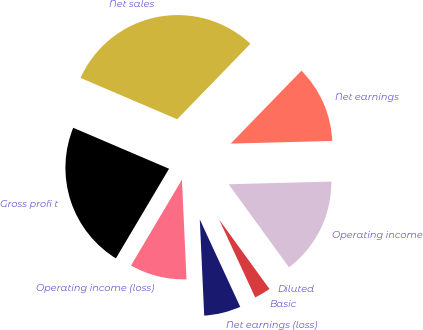Convert chart to OTSL. <chart><loc_0><loc_0><loc_500><loc_500><pie_chart><fcel>Net sales<fcel>Gross profi t<fcel>Operating income (loss)<fcel>Net earnings (loss)<fcel>Basic<fcel>Diluted<fcel>Operating income<fcel>Net earnings<nl><fcel>30.83%<fcel>22.91%<fcel>9.25%<fcel>6.17%<fcel>3.09%<fcel>0.0%<fcel>15.42%<fcel>12.33%<nl></chart> 